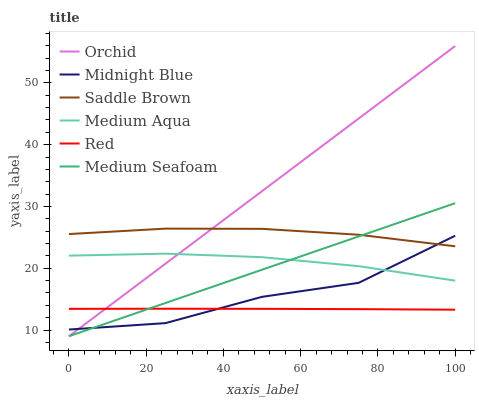Does Red have the minimum area under the curve?
Answer yes or no. Yes. Does Orchid have the maximum area under the curve?
Answer yes or no. Yes. Does Medium Seafoam have the minimum area under the curve?
Answer yes or no. No. Does Medium Seafoam have the maximum area under the curve?
Answer yes or no. No. Is Medium Seafoam the smoothest?
Answer yes or no. Yes. Is Midnight Blue the roughest?
Answer yes or no. Yes. Is Medium Aqua the smoothest?
Answer yes or no. No. Is Medium Aqua the roughest?
Answer yes or no. No. Does Medium Seafoam have the lowest value?
Answer yes or no. Yes. Does Medium Aqua have the lowest value?
Answer yes or no. No. Does Orchid have the highest value?
Answer yes or no. Yes. Does Medium Seafoam have the highest value?
Answer yes or no. No. Is Red less than Medium Aqua?
Answer yes or no. Yes. Is Medium Aqua greater than Red?
Answer yes or no. Yes. Does Red intersect Orchid?
Answer yes or no. Yes. Is Red less than Orchid?
Answer yes or no. No. Is Red greater than Orchid?
Answer yes or no. No. Does Red intersect Medium Aqua?
Answer yes or no. No. 